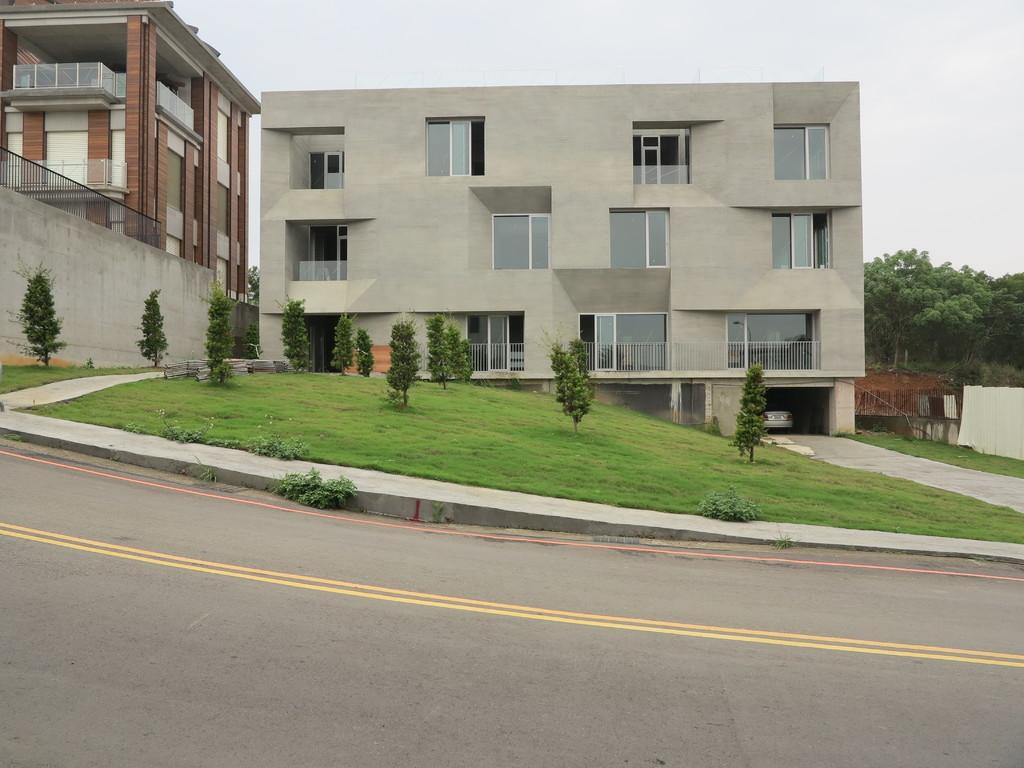What is the main feature of the image? There is a road in the image. What type of vegetation can be seen in the image? There are plants and grass in the image. What structures are present in the image? There are buildings in the image. What is on the left side of the image? There is a wall and a fence on the left side of the image. What can be seen in the background of the image? There are trees and the sky visible in the background of the image. What type of wine is being served at the minister's design meeting in the image? There is no wine, minister, or design meeting present in the image. 